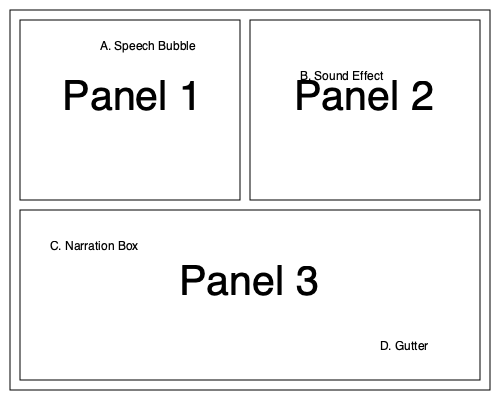Examine the labeled manga page layout above. Which element, typically found between panels, is crucial for creating a sense of time and space in manga storytelling? To answer this question, let's break down the elements of a manga page layout:

1. Panel: The individual frames that contain the artwork and tell the story sequentially.
2. Speech Bubble (A): Contains character dialogue.
3. Sound Effect (B): Represents non-verbal sounds in the story.
4. Narration Box (C): Provides additional story information or character thoughts.
5. Gutter (D): The space between panels.

The key element for creating a sense of time and space in manga storytelling is the gutter (D). Here's why:

1. Time: The gutter represents the passage of time between panels. Readers mentally fill in the gaps between panels, creating a sense of continuous action.
2. Space: The gutter also represents the physical space between scenes or viewpoints, allowing for transitions in location or perspective.
3. Closure: This concept, coined by Scott McCloud, refers to the reader's ability to connect separate panels into a cohesive narrative using the gutter as a bridge.
4. Pacing: The width of gutters can be manipulated to affect the story's pacing. Wider gutters can indicate longer time passages or more significant scene changes.
5. Reader engagement: The gutter actively involves the reader in the storytelling process, making manga a more interactive medium.

Therefore, while all elements contribute to manga storytelling, the gutter is uniquely crucial for creating the sense of time and space between panels.
Answer: Gutter 